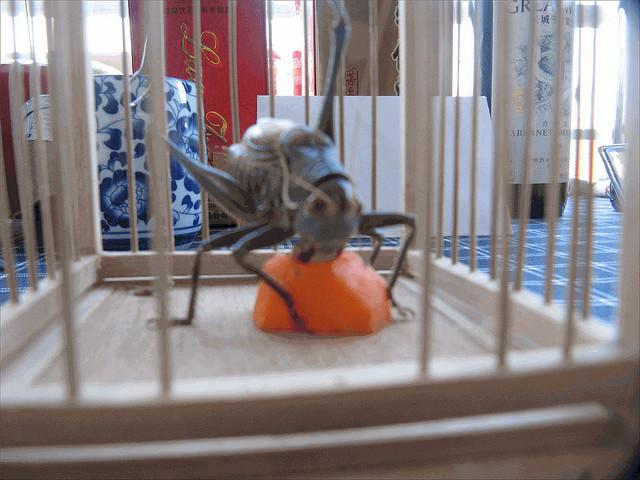What kind of animal do you see in the picture? grasshopper 